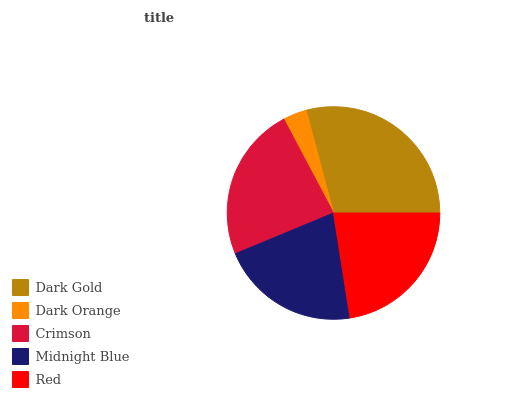Is Dark Orange the minimum?
Answer yes or no. Yes. Is Dark Gold the maximum?
Answer yes or no. Yes. Is Crimson the minimum?
Answer yes or no. No. Is Crimson the maximum?
Answer yes or no. No. Is Crimson greater than Dark Orange?
Answer yes or no. Yes. Is Dark Orange less than Crimson?
Answer yes or no. Yes. Is Dark Orange greater than Crimson?
Answer yes or no. No. Is Crimson less than Dark Orange?
Answer yes or no. No. Is Red the high median?
Answer yes or no. Yes. Is Red the low median?
Answer yes or no. Yes. Is Crimson the high median?
Answer yes or no. No. Is Crimson the low median?
Answer yes or no. No. 